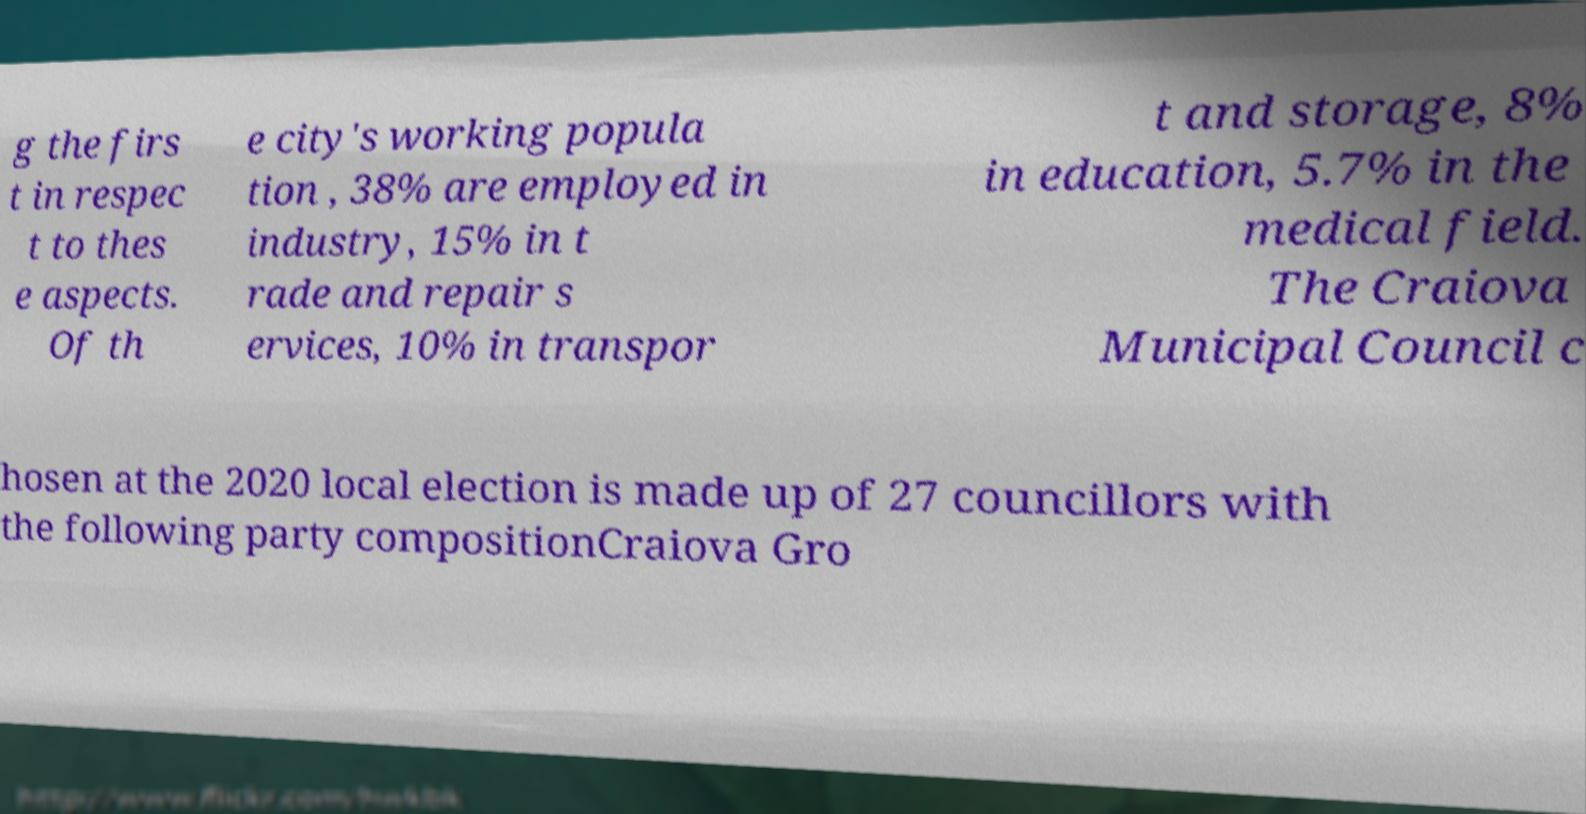What messages or text are displayed in this image? I need them in a readable, typed format. g the firs t in respec t to thes e aspects. Of th e city's working popula tion , 38% are employed in industry, 15% in t rade and repair s ervices, 10% in transpor t and storage, 8% in education, 5.7% in the medical field. The Craiova Municipal Council c hosen at the 2020 local election is made up of 27 councillors with the following party compositionCraiova Gro 